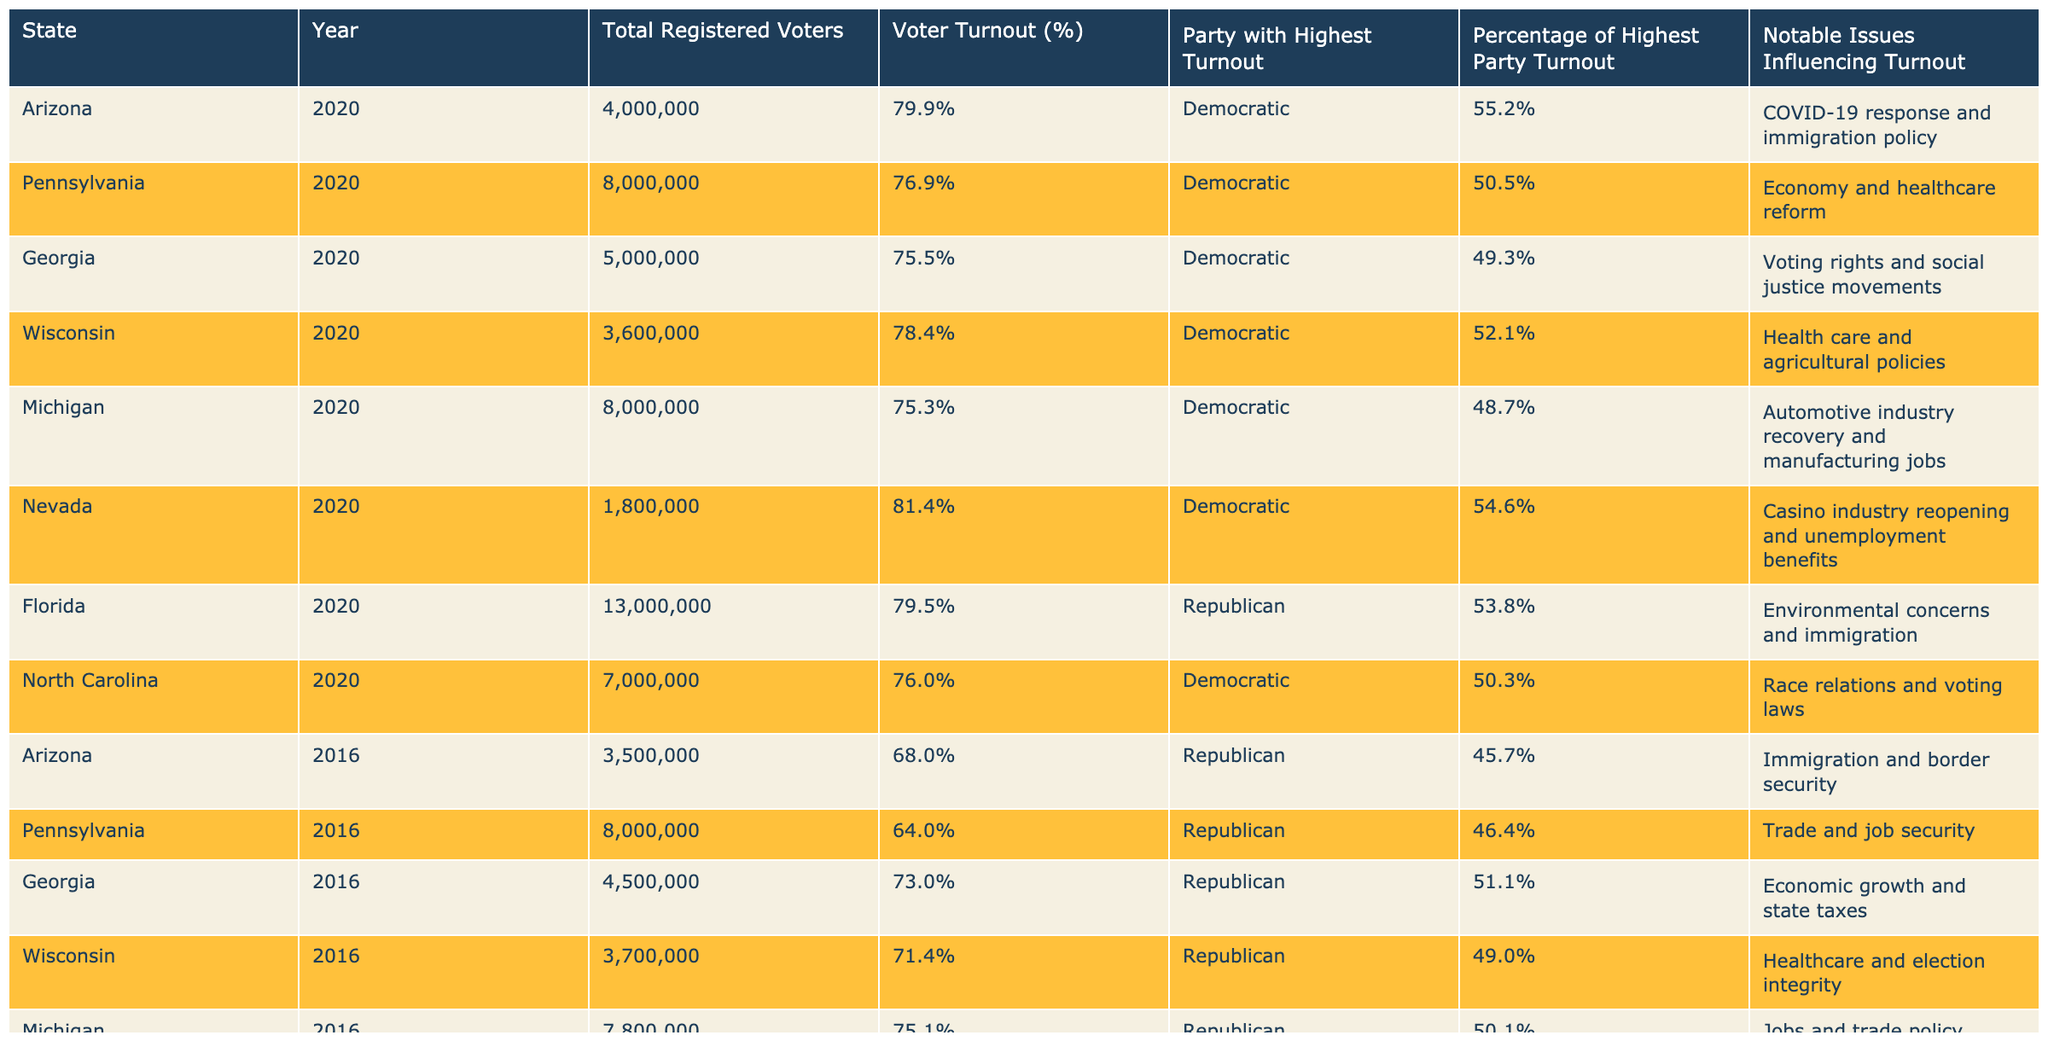What was the voter turnout percentage in Arizona during the 2020 election? The table shows that Arizona had a voter turnout of 79.9% in the year 2020.
Answer: 79.9% Which party had the highest turnout in Nevada in the 2020 election? In Nevada's 2020 election, the Democratic Party had the highest turnout at 54.6%.
Answer: Democratic What was the total number of registered voters in Florida for the 2016 election? The table indicates that Florida had a total of 13,000,000 registered voters in 2016.
Answer: 13,000,000 Which swing state had the lowest voter turnout in 2016? By comparing the turnout percentages from 2016, North Carolina at 69.8% had the lowest voter turnout among the listed states.
Answer: North Carolina Calculate the average voter turnout percentage for all states in the 2020 election. The total voter turnout percentages for the states in 2020 are 79.9, 76.9, 75.5, 78.4, 75.3, 81.4, 79.5, and 76.0. Summing these gives 609.5 and dividing by 8 results in an average of 76.1875%, which can be rounded to 76.2%.
Answer: 76.2% Is it true that the Democratic Party had the highest turnout in Florida during the 2020 election? The table shows that, in Florida, the Republican Party had the highest turnout at 53.8%, so this statement is false.
Answer: No Which state had the highest percentage of voter turnout in 2020? Looking through the table, Nevada stands out with the highest turnout at 81.4% in the 2020 election.
Answer: Nevada How much did Arizona’s voter turnout change from 2016 to 2020? Arizona's voter turnout increased from 68.0% in 2016 to 79.9% in 2020, which is an increase of 11.9%.
Answer: 11.9% What notable issue influenced voter turnout in Pennsylvania during the 2020 election? The table indicates that the notable issues influencing turnout in Pennsylvania were the economy and healthcare reform.
Answer: Economy and healthcare reform Which state's voter turnout percentage was closer to 75% in the 2020 election? By examining the percentages, Georgia's turnout was 75.5%, which is closest to 75%.
Answer: Georgia Did Michigan's voter turnout percentage increase or decrease from 2016 to 2020? Michigan's turnout decreased from 75.1% in 2016 to 75.3% in 2020, indicating a slight increase.
Answer: Increase 